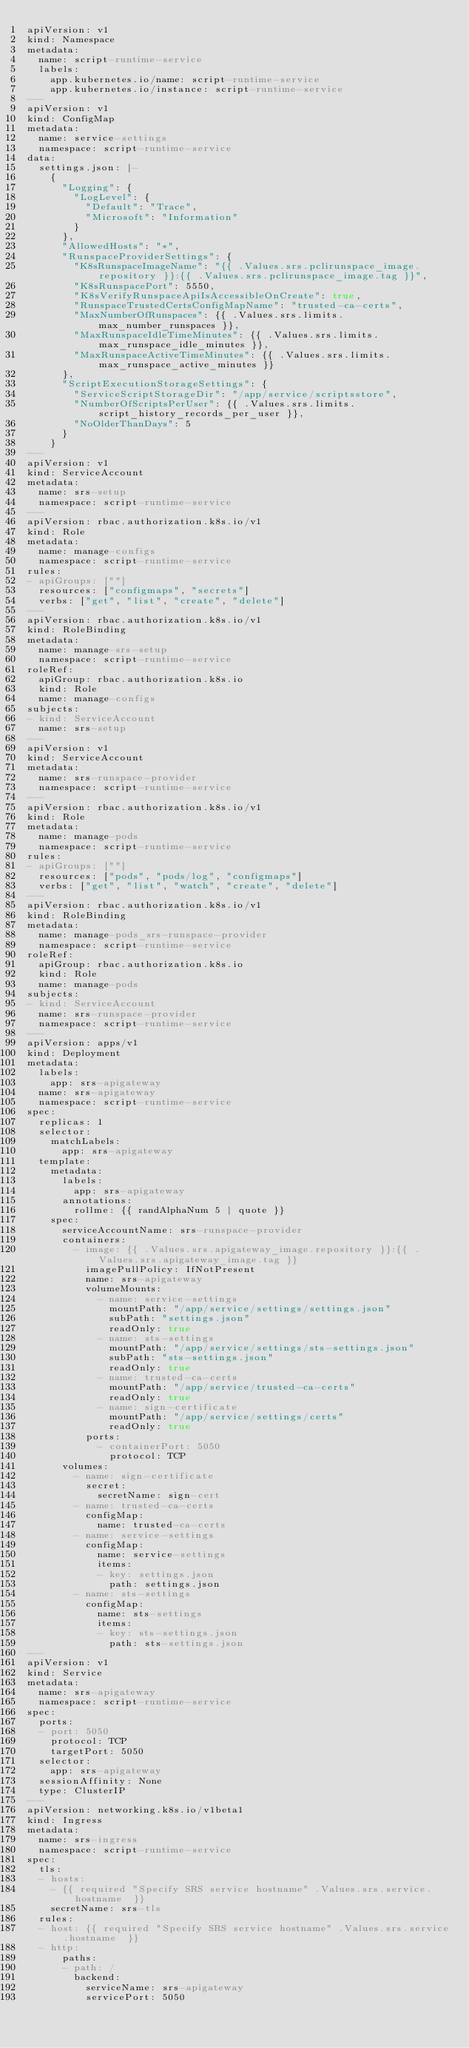Convert code to text. <code><loc_0><loc_0><loc_500><loc_500><_YAML_>apiVersion: v1
kind: Namespace
metadata:
  name: script-runtime-service
  labels:
    app.kubernetes.io/name: script-runtime-service
    app.kubernetes.io/instance: script-runtime-service
---
apiVersion: v1
kind: ConfigMap
metadata:
  name: service-settings
  namespace: script-runtime-service
data:
  settings.json: |-
    {
      "Logging": {
        "LogLevel": {
          "Default": "Trace",
          "Microsoft": "Information"
        }
      },
      "AllowedHosts": "*",
      "RunspaceProviderSettings": {
        "K8sRunspaceImageName": "{{ .Values.srs.pclirunspace_image.repository }}:{{ .Values.srs.pclirunspace_image.tag }}",
        "K8sRunspacePort": 5550,
        "K8sVerifyRunspaceApiIsAccessibleOnCreate": true,
        "RunspaceTrustedCertsConfigMapName": "trusted-ca-certs",
        "MaxNumberOfRunspaces": {{ .Values.srs.limits.max_number_runspaces }},
        "MaxRunspaceIdleTimeMinutes": {{ .Values.srs.limits.max_runspace_idle_minutes }},
        "MaxRunspaceActiveTimeMinutes": {{ .Values.srs.limits.max_runspace_active_minutes }}
      },
      "ScriptExecutionStorageSettings": {
        "ServiceScriptStorageDir": "/app/service/scriptsstore",
        "NumberOfScriptsPerUser": {{ .Values.srs.limits.script_history_records_per_user }},
        "NoOlderThanDays": 5
      }
    }
---
apiVersion: v1
kind: ServiceAccount
metadata:
  name: srs-setup
  namespace: script-runtime-service
---
apiVersion: rbac.authorization.k8s.io/v1
kind: Role
metadata:
  name: manage-configs
  namespace: script-runtime-service
rules:
- apiGroups: [""]
  resources: ["configmaps", "secrets"]
  verbs: ["get", "list", "create", "delete"]
---
apiVersion: rbac.authorization.k8s.io/v1
kind: RoleBinding
metadata:
  name: manage-srs-setup
  namespace: script-runtime-service
roleRef:
  apiGroup: rbac.authorization.k8s.io
  kind: Role
  name: manage-configs
subjects:
- kind: ServiceAccount
  name: srs-setup
---
apiVersion: v1
kind: ServiceAccount
metadata:
  name: srs-runspace-provider
  namespace: script-runtime-service
---
apiVersion: rbac.authorization.k8s.io/v1
kind: Role
metadata:
  name: manage-pods
  namespace: script-runtime-service
rules:
- apiGroups: [""]
  resources: ["pods", "pods/log", "configmaps"]
  verbs: ["get", "list", "watch", "create", "delete"]
---
apiVersion: rbac.authorization.k8s.io/v1
kind: RoleBinding
metadata:
  name: manage-pods_srs-runspace-provider
  namespace: script-runtime-service
roleRef:
  apiGroup: rbac.authorization.k8s.io
  kind: Role
  name: manage-pods
subjects:
- kind: ServiceAccount
  name: srs-runspace-provider
  namespace: script-runtime-service
---
apiVersion: apps/v1
kind: Deployment
metadata:
  labels:
    app: srs-apigateway
  name: srs-apigateway
  namespace: script-runtime-service
spec:
  replicas: 1
  selector:
    matchLabels:
      app: srs-apigateway
  template:
    metadata:
      labels:
        app: srs-apigateway
      annotations:
        rollme: {{ randAlphaNum 5 | quote }}
    spec:
      serviceAccountName: srs-runspace-provider
      containers:
        - image: {{ .Values.srs.apigateway_image.repository }}:{{ .Values.srs.apigateway_image.tag }}
          imagePullPolicy: IfNotPresent
          name: srs-apigateway
          volumeMounts:
            - name: service-settings
              mountPath: "/app/service/settings/settings.json"
              subPath: "settings.json"
              readOnly: true
            - name: sts-settings
              mountPath: "/app/service/settings/sts-settings.json"
              subPath: "sts-settings.json"
              readOnly: true
            - name: trusted-ca-certs
              mountPath: "/app/service/trusted-ca-certs"
              readOnly: true
            - name: sign-certificate
              mountPath: "/app/service/settings/certs"
              readOnly: true
          ports:
            - containerPort: 5050
              protocol: TCP
      volumes:
        - name: sign-certificate
          secret:
            secretName: sign-cert
        - name: trusted-ca-certs
          configMap:
            name: trusted-ca-certs
        - name: service-settings
          configMap:
            name: service-settings
            items:
            - key: settings.json
              path: settings.json
        - name: sts-settings
          configMap:
            name: sts-settings
            items:
            - key: sts-settings.json
              path: sts-settings.json
---
apiVersion: v1
kind: Service
metadata:
  name: srs-apigateway
  namespace: script-runtime-service
spec:
  ports:
  - port: 5050
    protocol: TCP
    targetPort: 5050
  selector:
    app: srs-apigateway
  sessionAffinity: None
  type: ClusterIP
---
apiVersion: networking.k8s.io/v1beta1
kind: Ingress
metadata:
  name: srs-ingress
  namespace: script-runtime-service
spec:
  tls:
  - hosts:
    - {{ required "Specify SRS service hostname" .Values.srs.service.hostname  }}
    secretName: srs-tls
  rules:
  - host: {{ required "Specify SRS service hostname" .Values.srs.service.hostname  }}
  - http:
      paths:
      - path: /
        backend:
          serviceName: srs-apigateway
          servicePort: 5050
</code> 